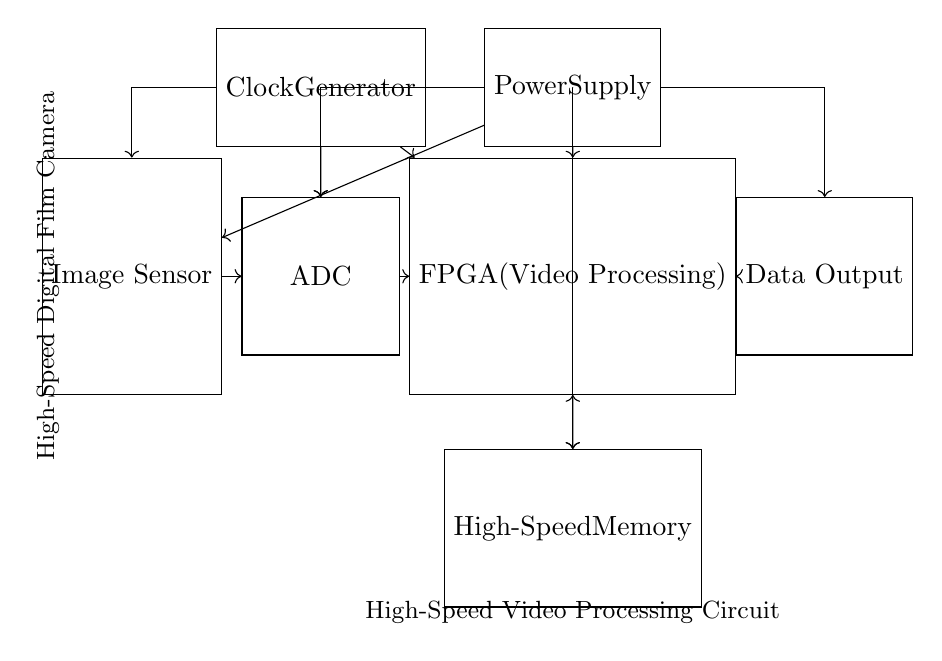What is the function of the image sensor? The image sensor captures light from the scene and converts it into an electrical signal for further processing.
Answer: Captures light What component receives the output from the ADC? According to the connections shown in the diagram, the FPGA receives the output from the ADC for video processing.
Answer: FPGA What supplies power to the entire circuit? The circuit uses a single power supply as depicted, supplying power to several components including the sensor, ADC, FPGA, memory, and data output.
Answer: Power Supply How does the clock generator influence data processing? The clock generator provides timing signals necessary for synchronizing operations between components, such as the sensor, ADC, and FPGA to ensure timely data transfer and processing.
Answer: Synchronization What type of memory is implemented in this circuit? The memory shown in the circuit is designed as high-speed memory, which is optimized for fast data retrieval and storage required for video processing.
Answer: High-Speed Memory Which component handles the final data output? The final data output is handled by the output component, as indicated by the directional arrow leading from the FPGA to the data output section.
Answer: Data Output 